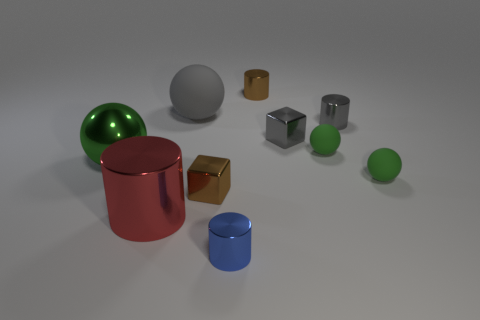There is a green thing that is on the left side of the blue thing; is its shape the same as the large gray matte object?
Give a very brief answer. Yes. There is a brown block that is left of the gray shiny object that is behind the gray shiny cube; what number of tiny brown objects are on the right side of it?
Offer a very short reply. 1. Are there any other things that are the same shape as the big gray object?
Offer a very short reply. Yes. What number of things are gray matte things or green objects?
Ensure brevity in your answer.  4. There is a big gray thing; is its shape the same as the green thing in front of the big green sphere?
Make the answer very short. Yes. The brown shiny thing that is behind the gray ball has what shape?
Your response must be concise. Cylinder. Is the shape of the big red metallic thing the same as the large gray thing?
Keep it short and to the point. No. There is a gray thing that is the same shape as the big green object; what size is it?
Make the answer very short. Large. Does the green sphere that is left of the blue shiny object have the same size as the large red cylinder?
Make the answer very short. Yes. What size is the thing that is both on the right side of the small gray cube and in front of the green shiny thing?
Keep it short and to the point. Small. 